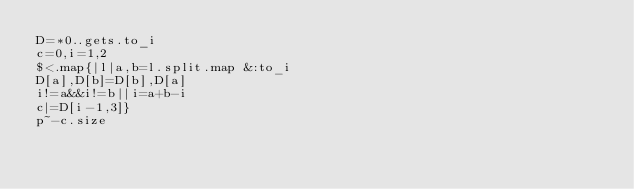Convert code to text. <code><loc_0><loc_0><loc_500><loc_500><_Ruby_>D=*0..gets.to_i
c=0,i=1,2
$<.map{|l|a,b=l.split.map &:to_i
D[a],D[b]=D[b],D[a]
i!=a&&i!=b||i=a+b-i
c|=D[i-1,3]}
p~-c.size</code> 